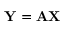Convert formula to latex. <formula><loc_0><loc_0><loc_500><loc_500>{ Y } = { A } { X }</formula> 